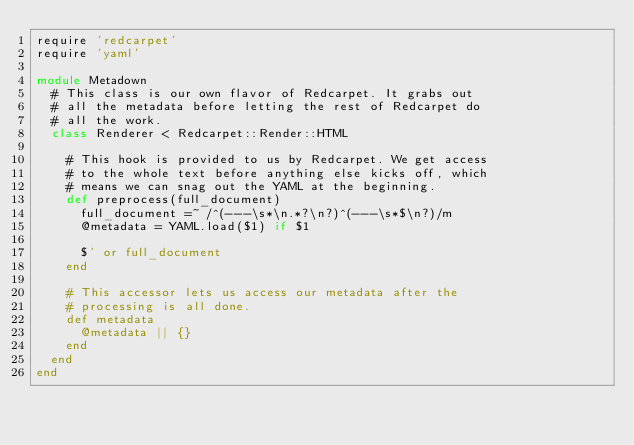<code> <loc_0><loc_0><loc_500><loc_500><_Ruby_>require 'redcarpet'
require 'yaml'

module Metadown
  # This class is our own flavor of Redcarpet. It grabs out
  # all the metadata before letting the rest of Redcarpet do
  # all the work.
  class Renderer < Redcarpet::Render::HTML

    # This hook is provided to us by Redcarpet. We get access
    # to the whole text before anything else kicks off, which
    # means we can snag out the YAML at the beginning.
    def preprocess(full_document)
      full_document =~ /^(---\s*\n.*?\n?)^(---\s*$\n?)/m
      @metadata = YAML.load($1) if $1

      $' or full_document
    end

    # This accessor lets us access our metadata after the
    # processing is all done.
    def metadata
      @metadata || {}
    end
  end
end
</code> 